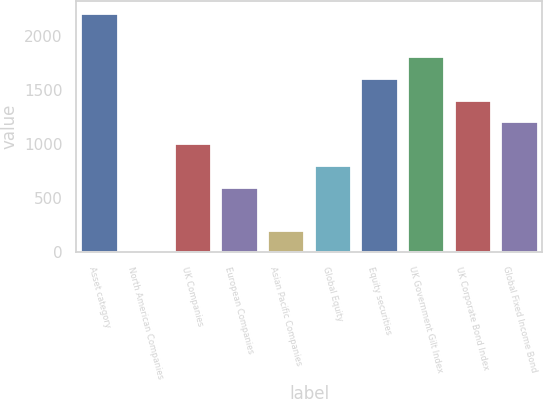Convert chart. <chart><loc_0><loc_0><loc_500><loc_500><bar_chart><fcel>Asset category<fcel>North American Companies<fcel>UK Companies<fcel>European Companies<fcel>Asian Pacific Companies<fcel>Global Equity<fcel>Equity securities<fcel>UK Government Gilt Index<fcel>UK Corporate Bond Index<fcel>Global Fixed Income Bond<nl><fcel>2214<fcel>3<fcel>1008<fcel>606<fcel>204<fcel>807<fcel>1611<fcel>1812<fcel>1410<fcel>1209<nl></chart> 